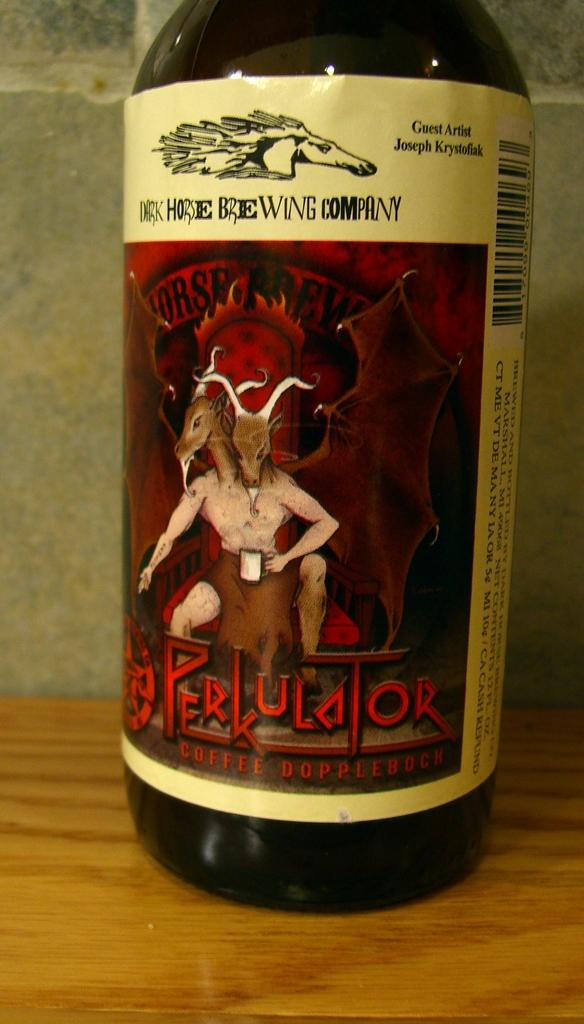<image>
Summarize the visual content of the image. a close up of a wine bottle label reading Rerkulator near a two headed goat person 